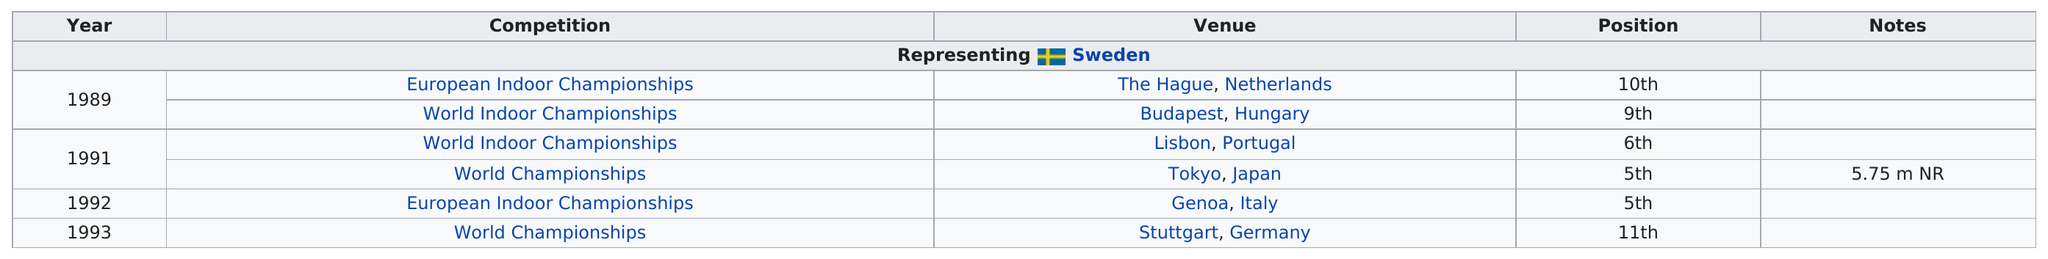Indicate a few pertinent items in this graphic. Peter Widen has the highest finish in all indoor championships, with a 5th-place finish. Peter Widen has competed in two World Indoor Championships. It is noted that the only championship in which the individual participated was held outside of Europe, and it took place in Tokyo, Japan. A total of 5 competitions were held between 1989 and 1992. Peter Widen has achieved the 6th position in the World Indoor Championships. 